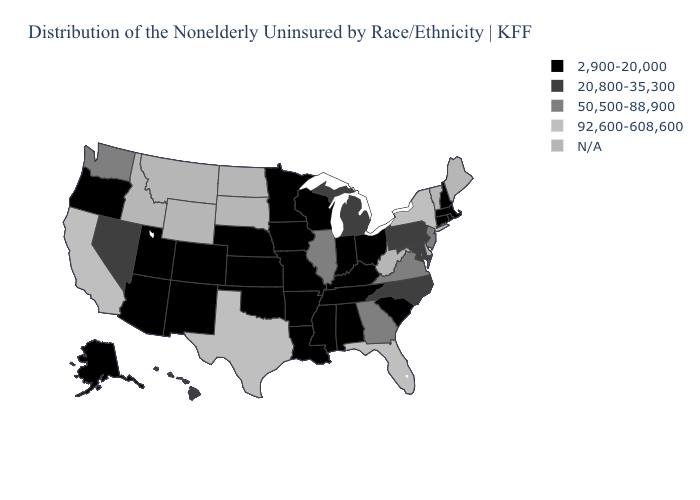Name the states that have a value in the range 92,600-608,600?
Answer briefly. California, Florida, New York, Texas. How many symbols are there in the legend?
Be succinct. 5. Among the states that border Kentucky , which have the highest value?
Answer briefly. Illinois, Virginia. Among the states that border New York , which have the lowest value?
Concise answer only. Connecticut, Massachusetts. Among the states that border Oklahoma , which have the highest value?
Give a very brief answer. Texas. What is the lowest value in the USA?
Keep it brief. 2,900-20,000. Name the states that have a value in the range 92,600-608,600?
Short answer required. California, Florida, New York, Texas. What is the lowest value in states that border Massachusetts?
Concise answer only. 2,900-20,000. What is the value of Iowa?
Quick response, please. 2,900-20,000. What is the value of Connecticut?
Concise answer only. 2,900-20,000. What is the highest value in the West ?
Write a very short answer. 92,600-608,600. Name the states that have a value in the range 50,500-88,900?
Give a very brief answer. Georgia, Illinois, New Jersey, Virginia, Washington. Name the states that have a value in the range 2,900-20,000?
Answer briefly. Alabama, Alaska, Arizona, Arkansas, Colorado, Connecticut, Indiana, Iowa, Kansas, Kentucky, Louisiana, Massachusetts, Minnesota, Mississippi, Missouri, Nebraska, New Hampshire, New Mexico, Ohio, Oklahoma, Oregon, Rhode Island, South Carolina, Tennessee, Utah, Wisconsin. Does California have the lowest value in the West?
Give a very brief answer. No. Does Mississippi have the lowest value in the USA?
Concise answer only. Yes. 